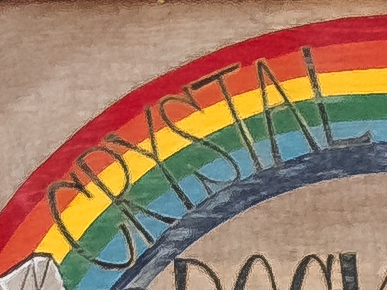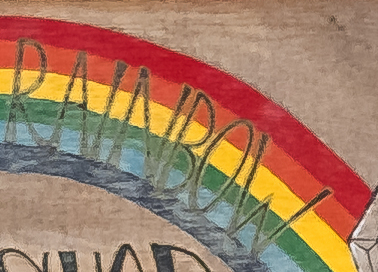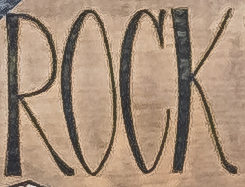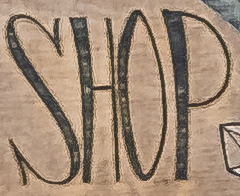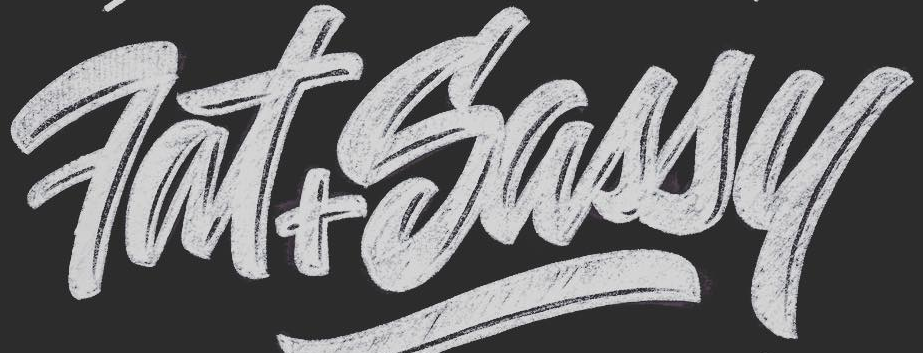What text is displayed in these images sequentially, separated by a semicolon? CRYSTAL; RNNBOW; ROCK; SHOP; Fat+Sassy 